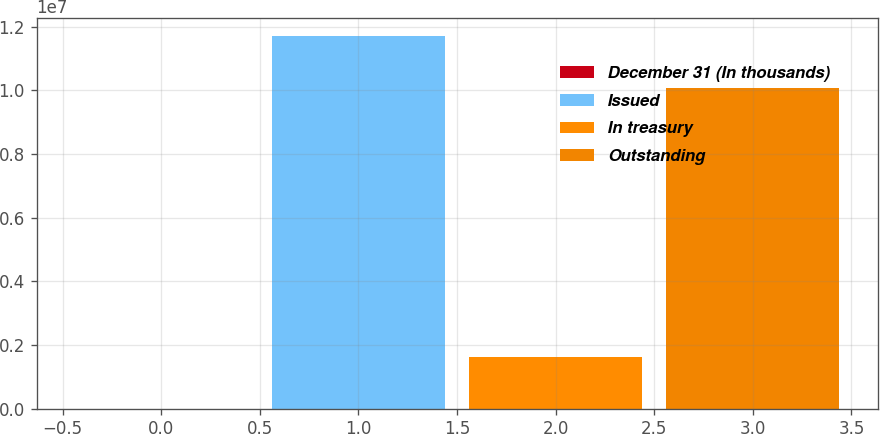Convert chart to OTSL. <chart><loc_0><loc_0><loc_500><loc_500><bar_chart><fcel>December 31 (In thousands)<fcel>Issued<fcel>In treasury<fcel>Outstanding<nl><fcel>2013<fcel>1.16938e+07<fcel>1.63296e+06<fcel>1.00609e+07<nl></chart> 